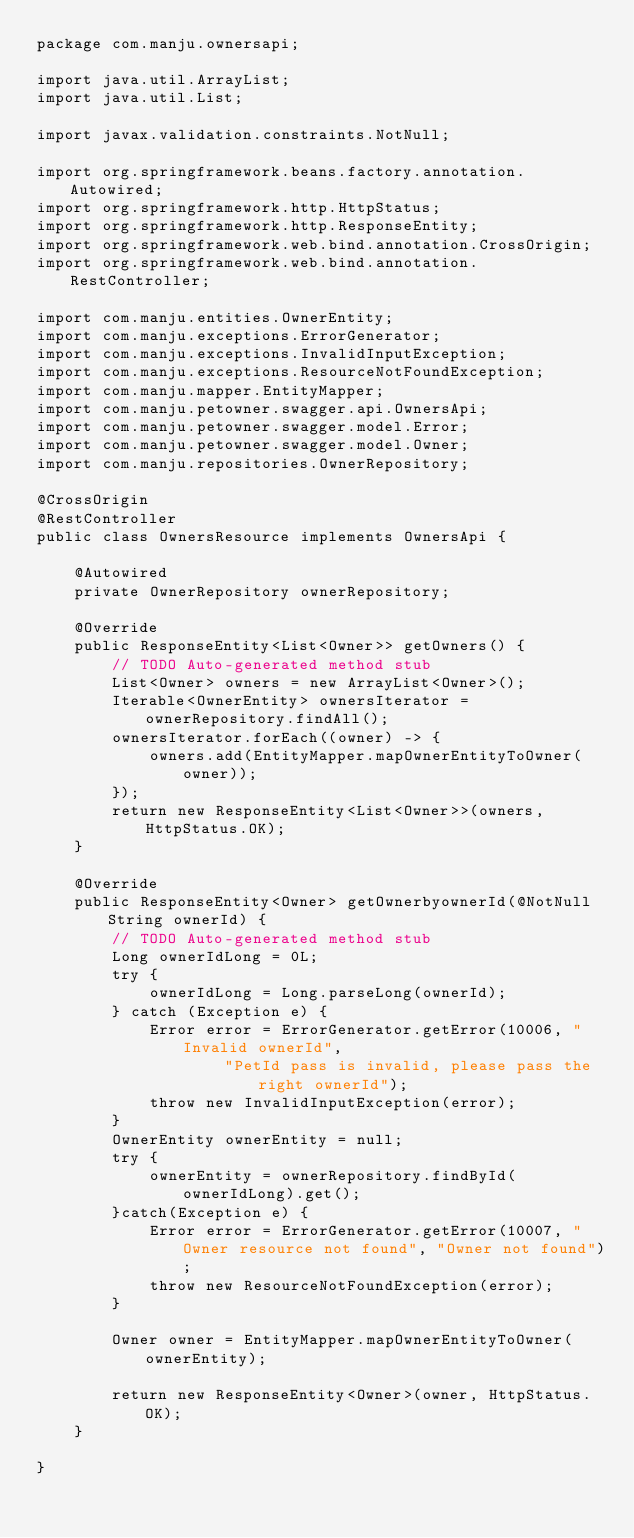<code> <loc_0><loc_0><loc_500><loc_500><_Java_>package com.manju.ownersapi;

import java.util.ArrayList;
import java.util.List;

import javax.validation.constraints.NotNull;

import org.springframework.beans.factory.annotation.Autowired;
import org.springframework.http.HttpStatus;
import org.springframework.http.ResponseEntity;
import org.springframework.web.bind.annotation.CrossOrigin;
import org.springframework.web.bind.annotation.RestController;

import com.manju.entities.OwnerEntity;
import com.manju.exceptions.ErrorGenerator;
import com.manju.exceptions.InvalidInputException;
import com.manju.exceptions.ResourceNotFoundException;
import com.manju.mapper.EntityMapper;
import com.manju.petowner.swagger.api.OwnersApi;
import com.manju.petowner.swagger.model.Error;
import com.manju.petowner.swagger.model.Owner;
import com.manju.repositories.OwnerRepository;

@CrossOrigin
@RestController
public class OwnersResource implements OwnersApi {

	@Autowired
	private OwnerRepository ownerRepository;

	@Override
	public ResponseEntity<List<Owner>> getOwners() {
		// TODO Auto-generated method stub
		List<Owner> owners = new ArrayList<Owner>();
		Iterable<OwnerEntity> ownersIterator = ownerRepository.findAll();
		ownersIterator.forEach((owner) -> {
			owners.add(EntityMapper.mapOwnerEntityToOwner(owner));
		});
		return new ResponseEntity<List<Owner>>(owners, HttpStatus.OK);
	}

	@Override
	public ResponseEntity<Owner> getOwnerbyownerId(@NotNull String ownerId) {
		// TODO Auto-generated method stub
		Long ownerIdLong = 0L;
		try {
			ownerIdLong = Long.parseLong(ownerId);
		} catch (Exception e) {
			Error error = ErrorGenerator.getError(10006, "Invalid ownerId",
					"PetId pass is invalid, please pass the right ownerId");
			throw new InvalidInputException(error);
		}
		OwnerEntity ownerEntity = null;
		try {
			ownerEntity = ownerRepository.findById(ownerIdLong).get();
		}catch(Exception e) {
			Error error = ErrorGenerator.getError(10007, "Owner resource not found", "Owner not found");
			throw new ResourceNotFoundException(error);
		}
		
		Owner owner = EntityMapper.mapOwnerEntityToOwner(ownerEntity);
		
		return new ResponseEntity<Owner>(owner, HttpStatus.OK);
	}

}
</code> 